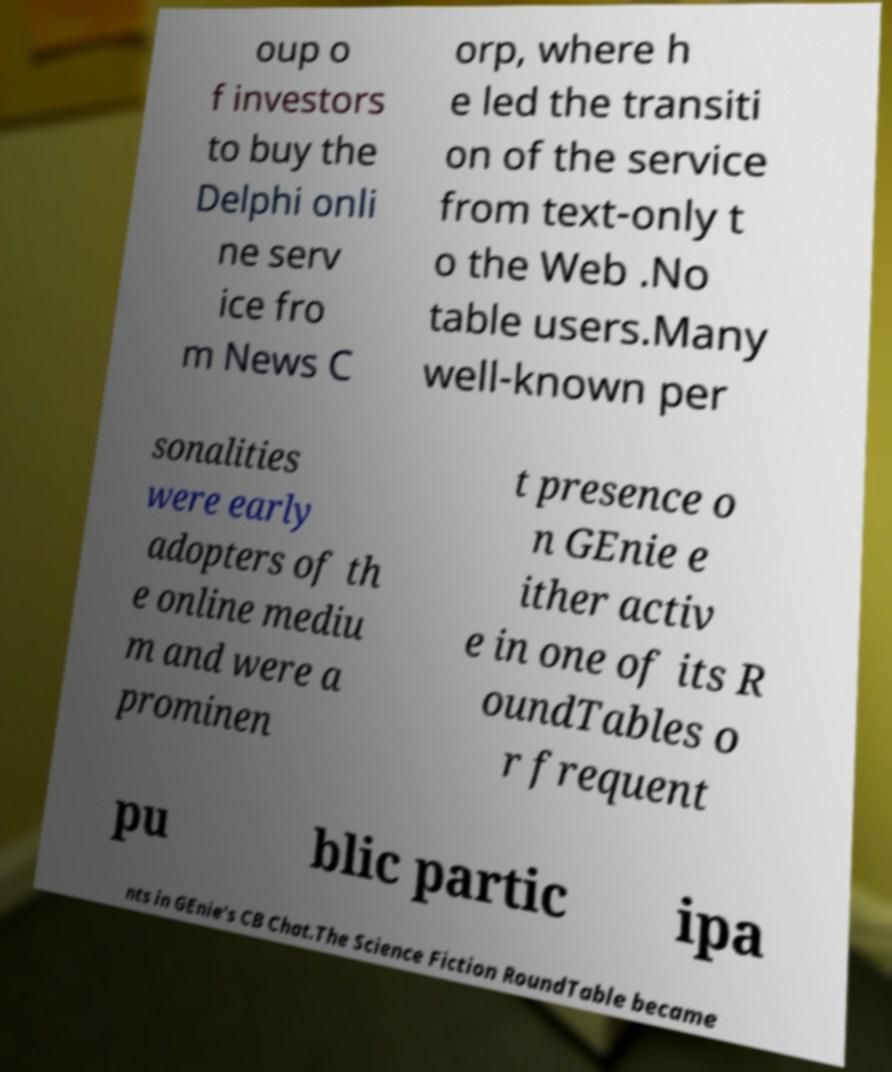Could you assist in decoding the text presented in this image and type it out clearly? oup o f investors to buy the Delphi onli ne serv ice fro m News C orp, where h e led the transiti on of the service from text-only t o the Web .No table users.Many well-known per sonalities were early adopters of th e online mediu m and were a prominen t presence o n GEnie e ither activ e in one of its R oundTables o r frequent pu blic partic ipa nts in GEnie's CB Chat.The Science Fiction RoundTable became 